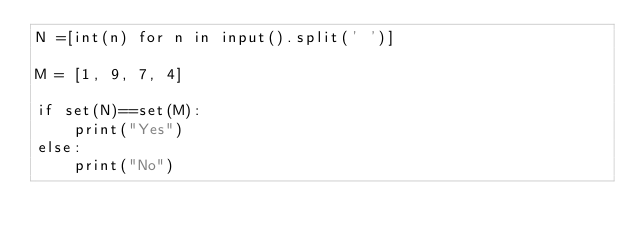<code> <loc_0><loc_0><loc_500><loc_500><_Python_>N =[int(n) for n in input().split(' ')]
 
M = [1, 9, 7, 4]
 
if set(N)==set(M):
    print("Yes")
else:
    print("No")</code> 